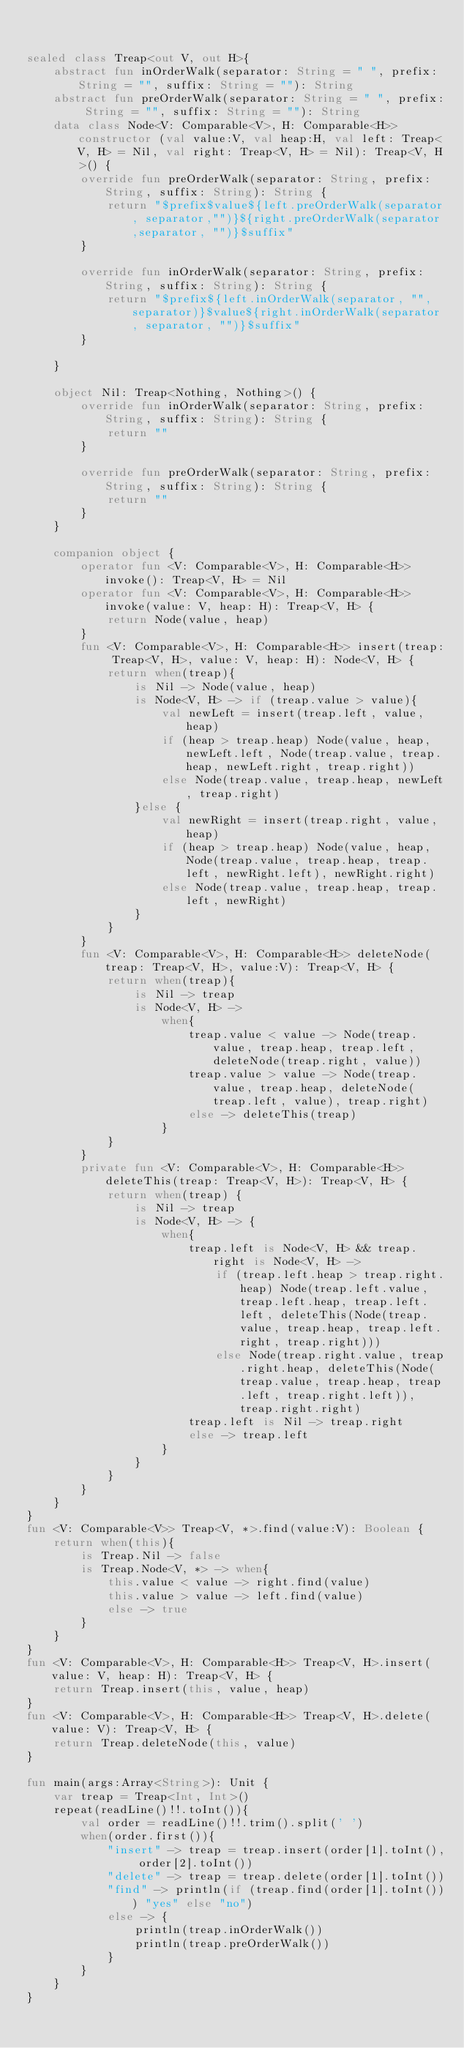Convert code to text. <code><loc_0><loc_0><loc_500><loc_500><_Kotlin_>

sealed class Treap<out V, out H>{
    abstract fun inOrderWalk(separator: String = " ", prefix: String = "", suffix: String = ""): String
    abstract fun preOrderWalk(separator: String = " ", prefix: String = "", suffix: String = ""): String
    data class Node<V: Comparable<V>, H: Comparable<H>> constructor (val value:V, val heap:H, val left: Treap<V, H> = Nil, val right: Treap<V, H> = Nil): Treap<V, H>() {
        override fun preOrderWalk(separator: String, prefix: String, suffix: String): String {
            return "$prefix$value${left.preOrderWalk(separator, separator,"")}${right.preOrderWalk(separator,separator, "")}$suffix"
        }

        override fun inOrderWalk(separator: String, prefix: String, suffix: String): String {
            return "$prefix${left.inOrderWalk(separator, "", separator)}$value${right.inOrderWalk(separator, separator, "")}$suffix"
        }

    }

    object Nil: Treap<Nothing, Nothing>() {
        override fun inOrderWalk(separator: String, prefix: String, suffix: String): String {
            return ""
        }

        override fun preOrderWalk(separator: String, prefix: String, suffix: String): String {
            return ""
        }
    }

    companion object {
        operator fun <V: Comparable<V>, H: Comparable<H>>invoke(): Treap<V, H> = Nil
        operator fun <V: Comparable<V>, H: Comparable<H>>invoke(value: V, heap: H): Treap<V, H> {
            return Node(value, heap)
        }
        fun <V: Comparable<V>, H: Comparable<H>> insert(treap: Treap<V, H>, value: V, heap: H): Node<V, H> {
            return when(treap){
                is Nil -> Node(value, heap)
                is Node<V, H> -> if (treap.value > value){
                    val newLeft = insert(treap.left, value, heap)
                    if (heap > treap.heap) Node(value, heap, newLeft.left, Node(treap.value, treap.heap, newLeft.right, treap.right))
                    else Node(treap.value, treap.heap, newLeft, treap.right)
                }else {
                    val newRight = insert(treap.right, value, heap)
                    if (heap > treap.heap) Node(value, heap, Node(treap.value, treap.heap, treap.left, newRight.left), newRight.right)
                    else Node(treap.value, treap.heap, treap.left, newRight)
                }
            }
        }
        fun <V: Comparable<V>, H: Comparable<H>> deleteNode(treap: Treap<V, H>, value:V): Treap<V, H> {
            return when(treap){
                is Nil -> treap
                is Node<V, H> ->
                    when{
                        treap.value < value -> Node(treap.value, treap.heap, treap.left, deleteNode(treap.right, value))
                        treap.value > value -> Node(treap.value, treap.heap, deleteNode(treap.left, value), treap.right)
                        else -> deleteThis(treap)
                    }
            }
        }
        private fun <V: Comparable<V>, H: Comparable<H>> deleteThis(treap: Treap<V, H>): Treap<V, H> {
            return when(treap) {
                is Nil -> treap
                is Node<V, H> -> {
                    when{
                        treap.left is Node<V, H> && treap.right is Node<V, H> ->
                            if (treap.left.heap > treap.right.heap) Node(treap.left.value, treap.left.heap, treap.left.left, deleteThis(Node(treap.value, treap.heap, treap.left.right, treap.right)))
                            else Node(treap.right.value, treap.right.heap, deleteThis(Node(treap.value, treap.heap, treap.left, treap.right.left)), treap.right.right)
                        treap.left is Nil -> treap.right
                        else -> treap.left
                    }
                }
            }
        }
    }
}
fun <V: Comparable<V>> Treap<V, *>.find(value:V): Boolean {
    return when(this){
        is Treap.Nil -> false
        is Treap.Node<V, *> -> when{
            this.value < value -> right.find(value)
            this.value > value -> left.find(value)
            else -> true
        }
    }
}
fun <V: Comparable<V>, H: Comparable<H>> Treap<V, H>.insert(value: V, heap: H): Treap<V, H> {
    return Treap.insert(this, value, heap)
}
fun <V: Comparable<V>, H: Comparable<H>> Treap<V, H>.delete(value: V): Treap<V, H> {
    return Treap.deleteNode(this, value)
}

fun main(args:Array<String>): Unit {
    var treap = Treap<Int, Int>()
    repeat(readLine()!!.toInt()){
        val order = readLine()!!.trim().split(' ')
        when(order.first()){
            "insert" -> treap = treap.insert(order[1].toInt(), order[2].toInt())
            "delete" -> treap = treap.delete(order[1].toInt())
            "find" -> println(if (treap.find(order[1].toInt())) "yes" else "no")
            else -> {
                println(treap.inOrderWalk())
                println(treap.preOrderWalk())
            }
        }
    }
}
</code> 